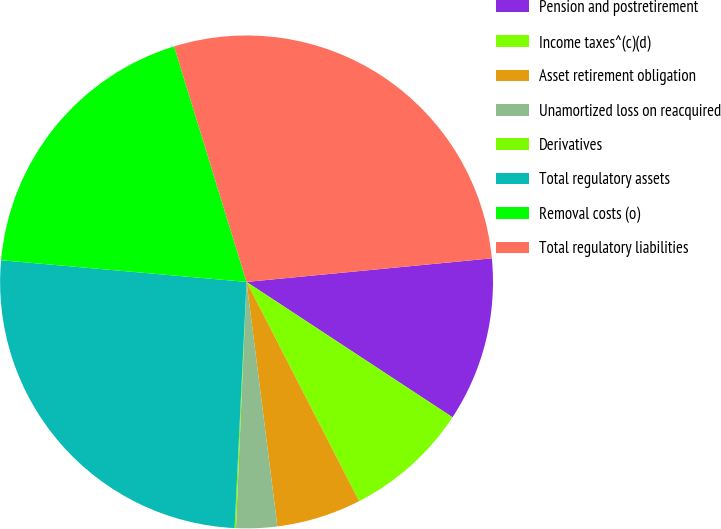Convert chart. <chart><loc_0><loc_0><loc_500><loc_500><pie_chart><fcel>Pension and postretirement<fcel>Income taxes^(c)(d)<fcel>Asset retirement obligation<fcel>Unamortized loss on reacquired<fcel>Derivatives<fcel>Total regulatory assets<fcel>Removal costs (o)<fcel>Total regulatory liabilities<nl><fcel>10.78%<fcel>8.2%<fcel>5.55%<fcel>2.68%<fcel>0.09%<fcel>25.63%<fcel>18.85%<fcel>28.22%<nl></chart> 